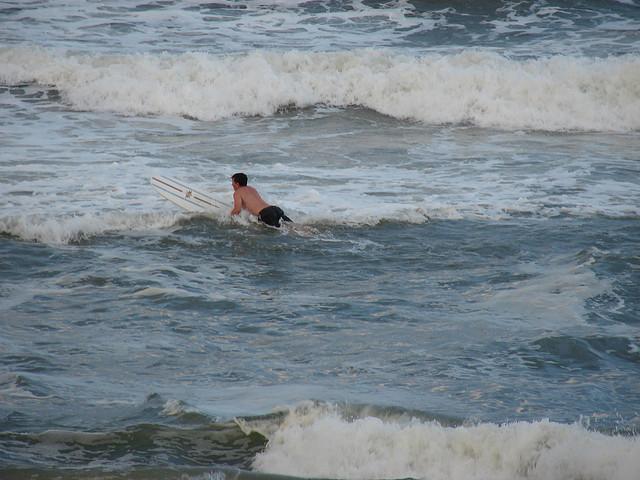How many people do you see?
Short answer required. 1. Are the waves big?
Give a very brief answer. No. Is this at the beach?
Quick response, please. Yes. What is the man lying on?
Write a very short answer. Surfboard. 